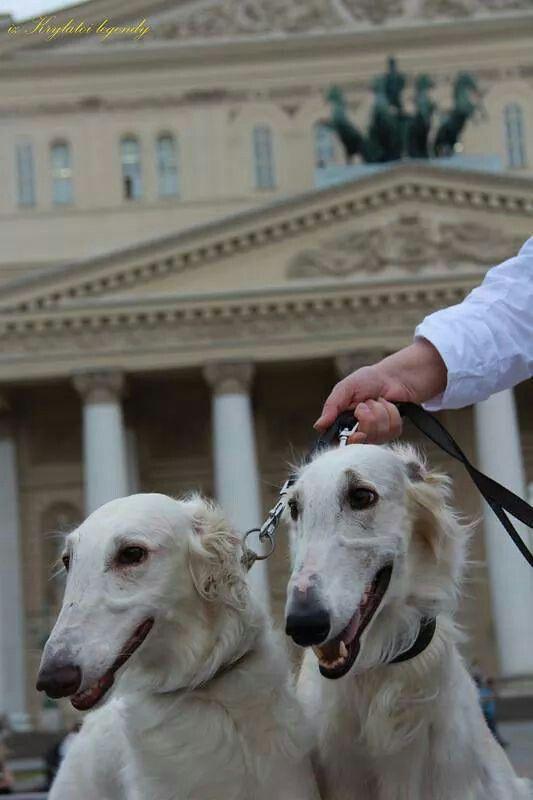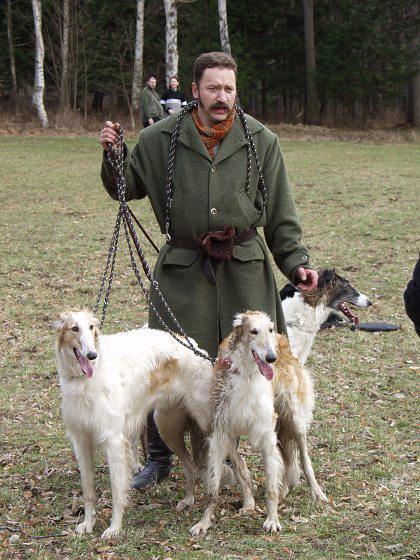The first image is the image on the left, the second image is the image on the right. Considering the images on both sides, is "Two hounds with left-turned faces are in the foreground of the left image, and the right image includes at least three hounds." valid? Answer yes or no. Yes. The first image is the image on the left, the second image is the image on the right. For the images displayed, is the sentence "In one image there are two white dogs and in the other image there are three dogs." factually correct? Answer yes or no. Yes. 